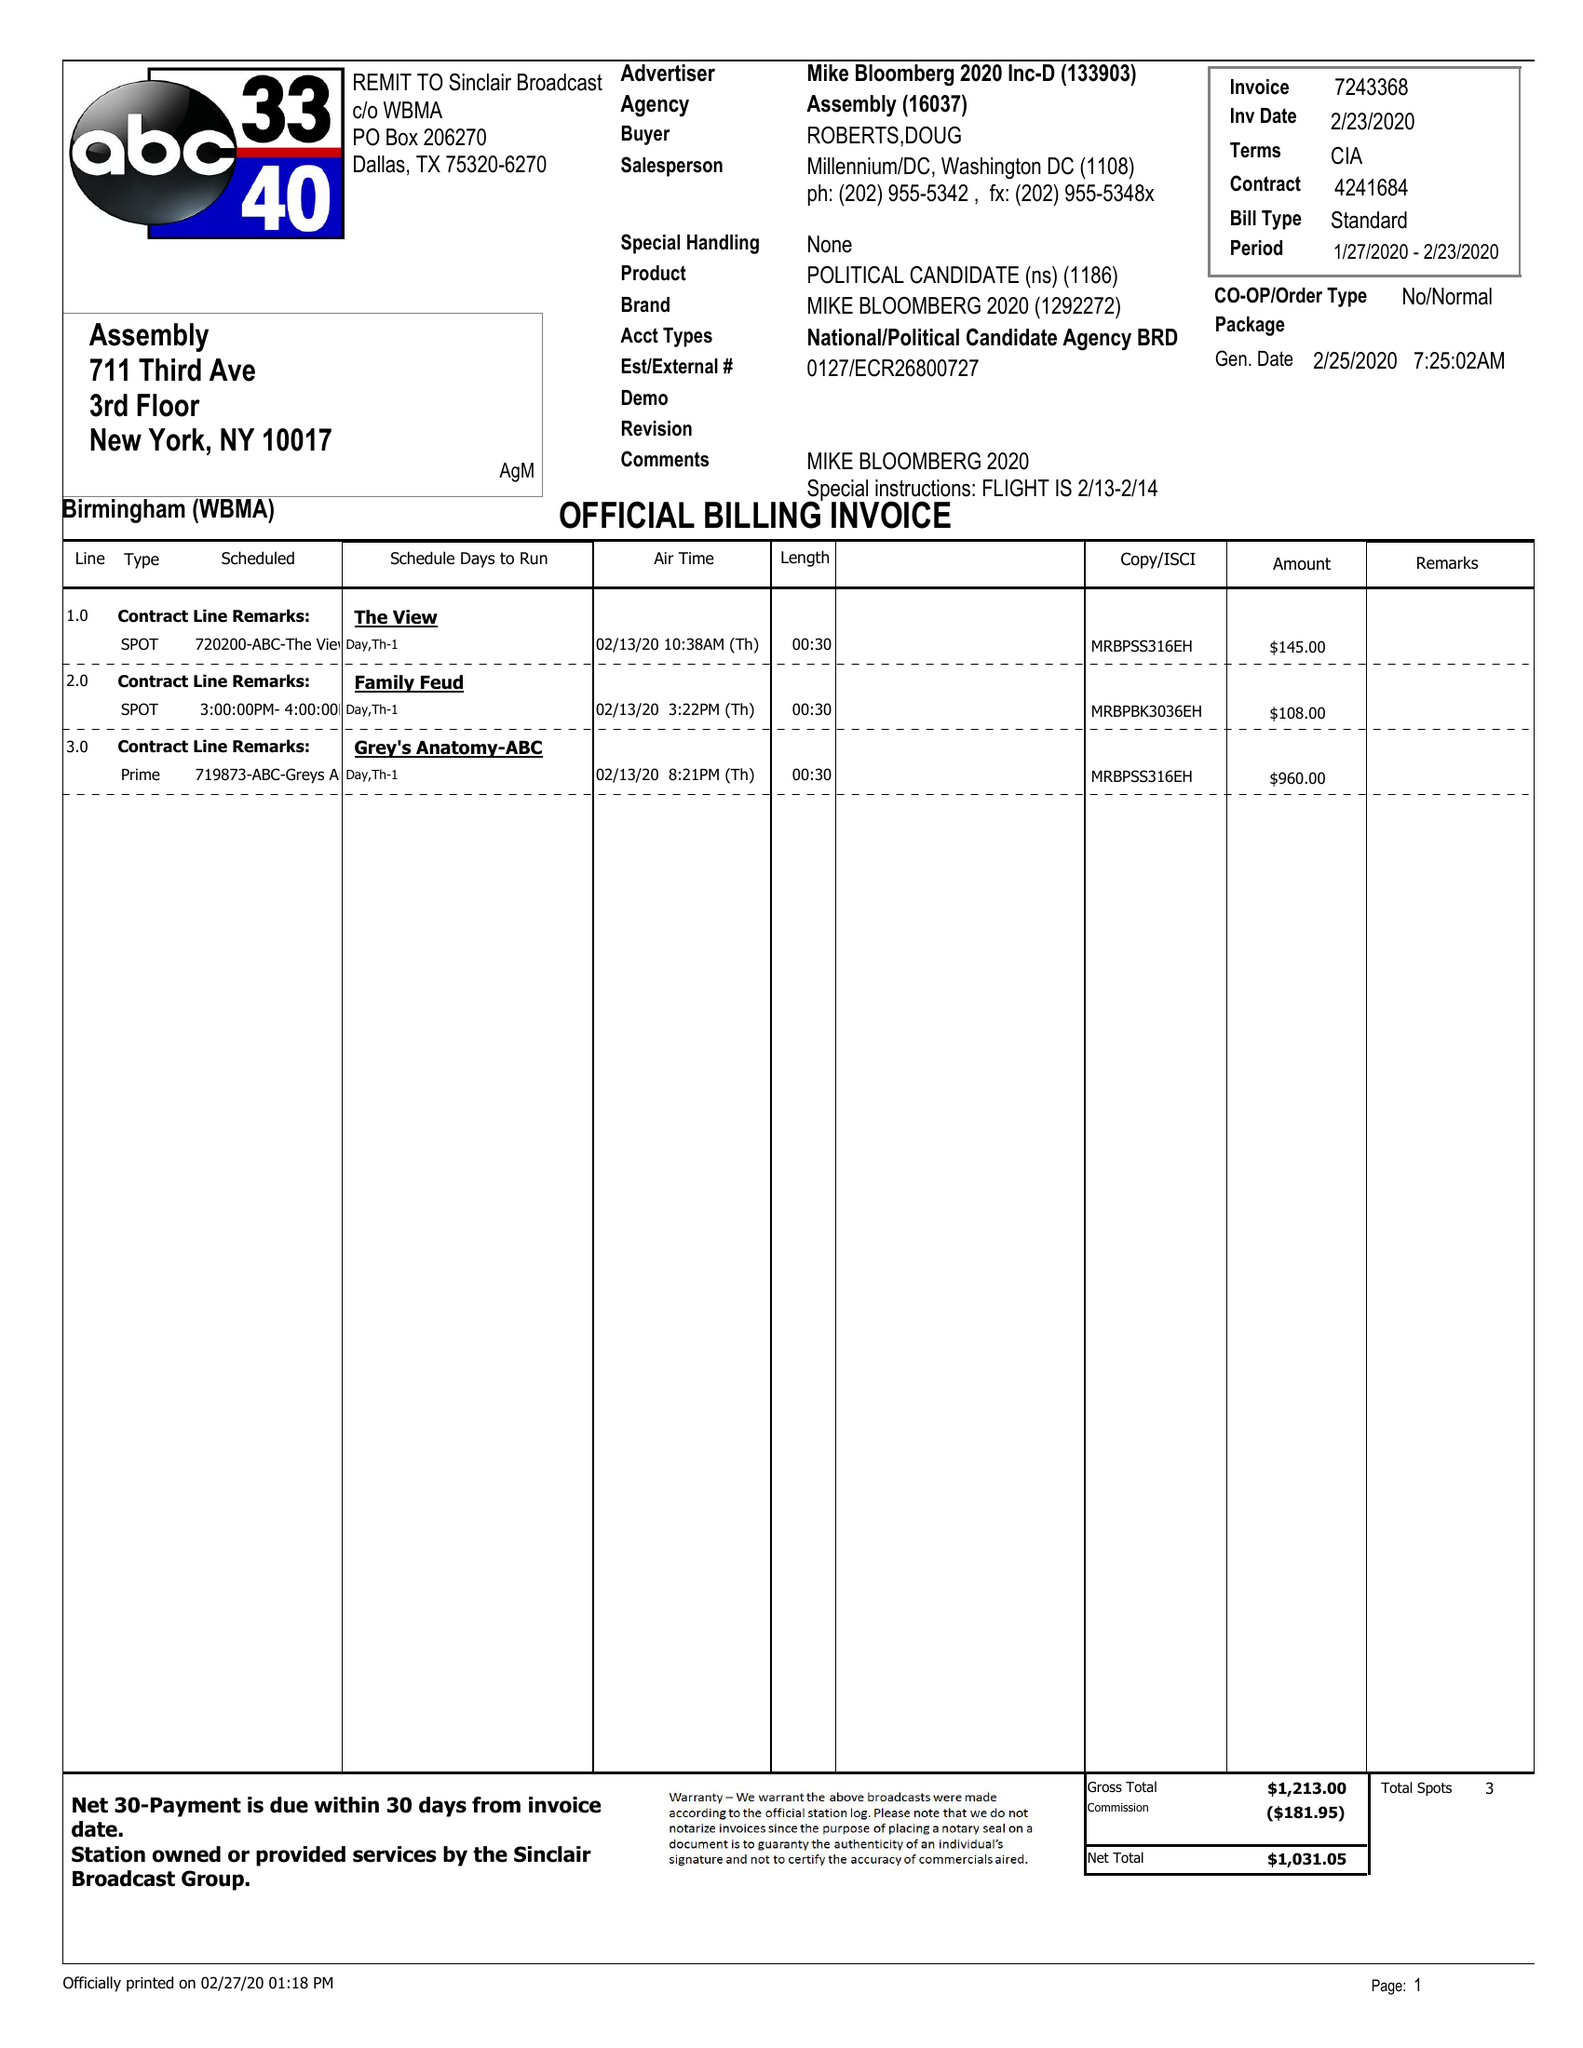What is the value for the flight_to?
Answer the question using a single word or phrase. 02/23/20 